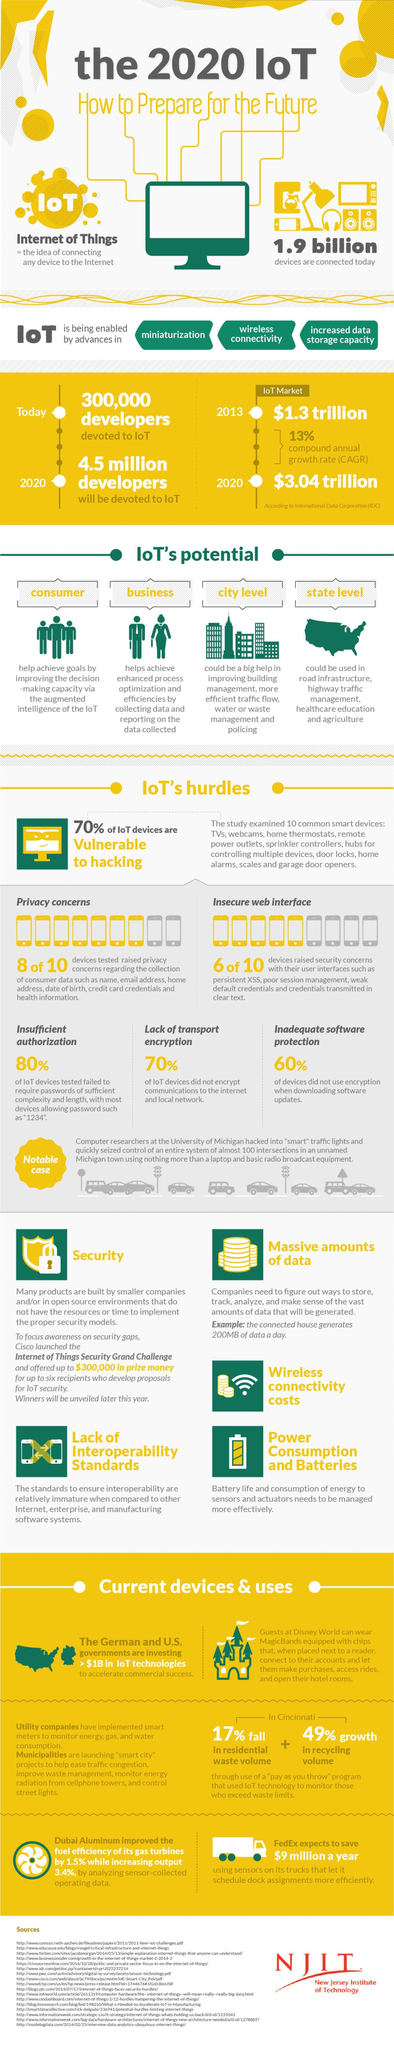Outline some significant characteristics in this image. According to the data, approximately 60% of IoT devices did not use encryption when downloading software updates. According to the IDC, the market value of the IoT in 2013 was $1.3 trillion. Approximately 70% of IoT devices do not encrypt their communications to the internet and local network, posing a significant security risk. Approximately 30% of IoT devices are not vulnerable to hacking. According to the IDC, the IoT market was valued at $3.04 trillion in 2020. 